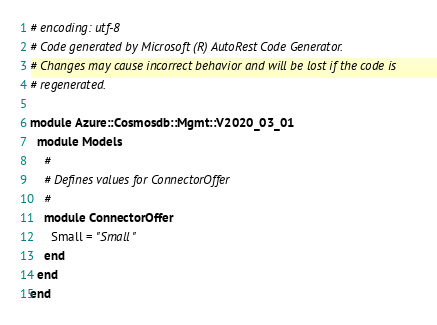Convert code to text. <code><loc_0><loc_0><loc_500><loc_500><_Ruby_># encoding: utf-8
# Code generated by Microsoft (R) AutoRest Code Generator.
# Changes may cause incorrect behavior and will be lost if the code is
# regenerated.

module Azure::Cosmosdb::Mgmt::V2020_03_01
  module Models
    #
    # Defines values for ConnectorOffer
    #
    module ConnectorOffer
      Small = "Small"
    end
  end
end
</code> 